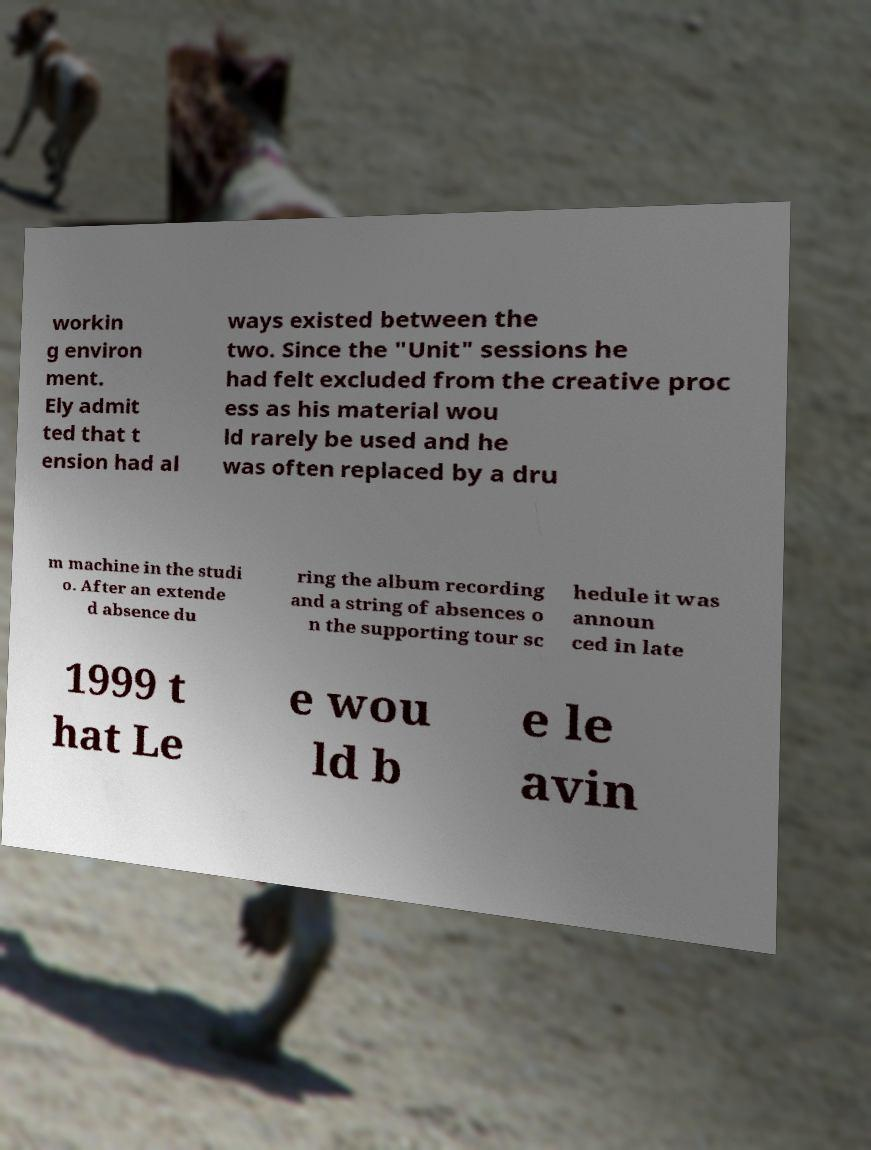Could you extract and type out the text from this image? workin g environ ment. Ely admit ted that t ension had al ways existed between the two. Since the "Unit" sessions he had felt excluded from the creative proc ess as his material wou ld rarely be used and he was often replaced by a dru m machine in the studi o. After an extende d absence du ring the album recording and a string of absences o n the supporting tour sc hedule it was announ ced in late 1999 t hat Le e wou ld b e le avin 